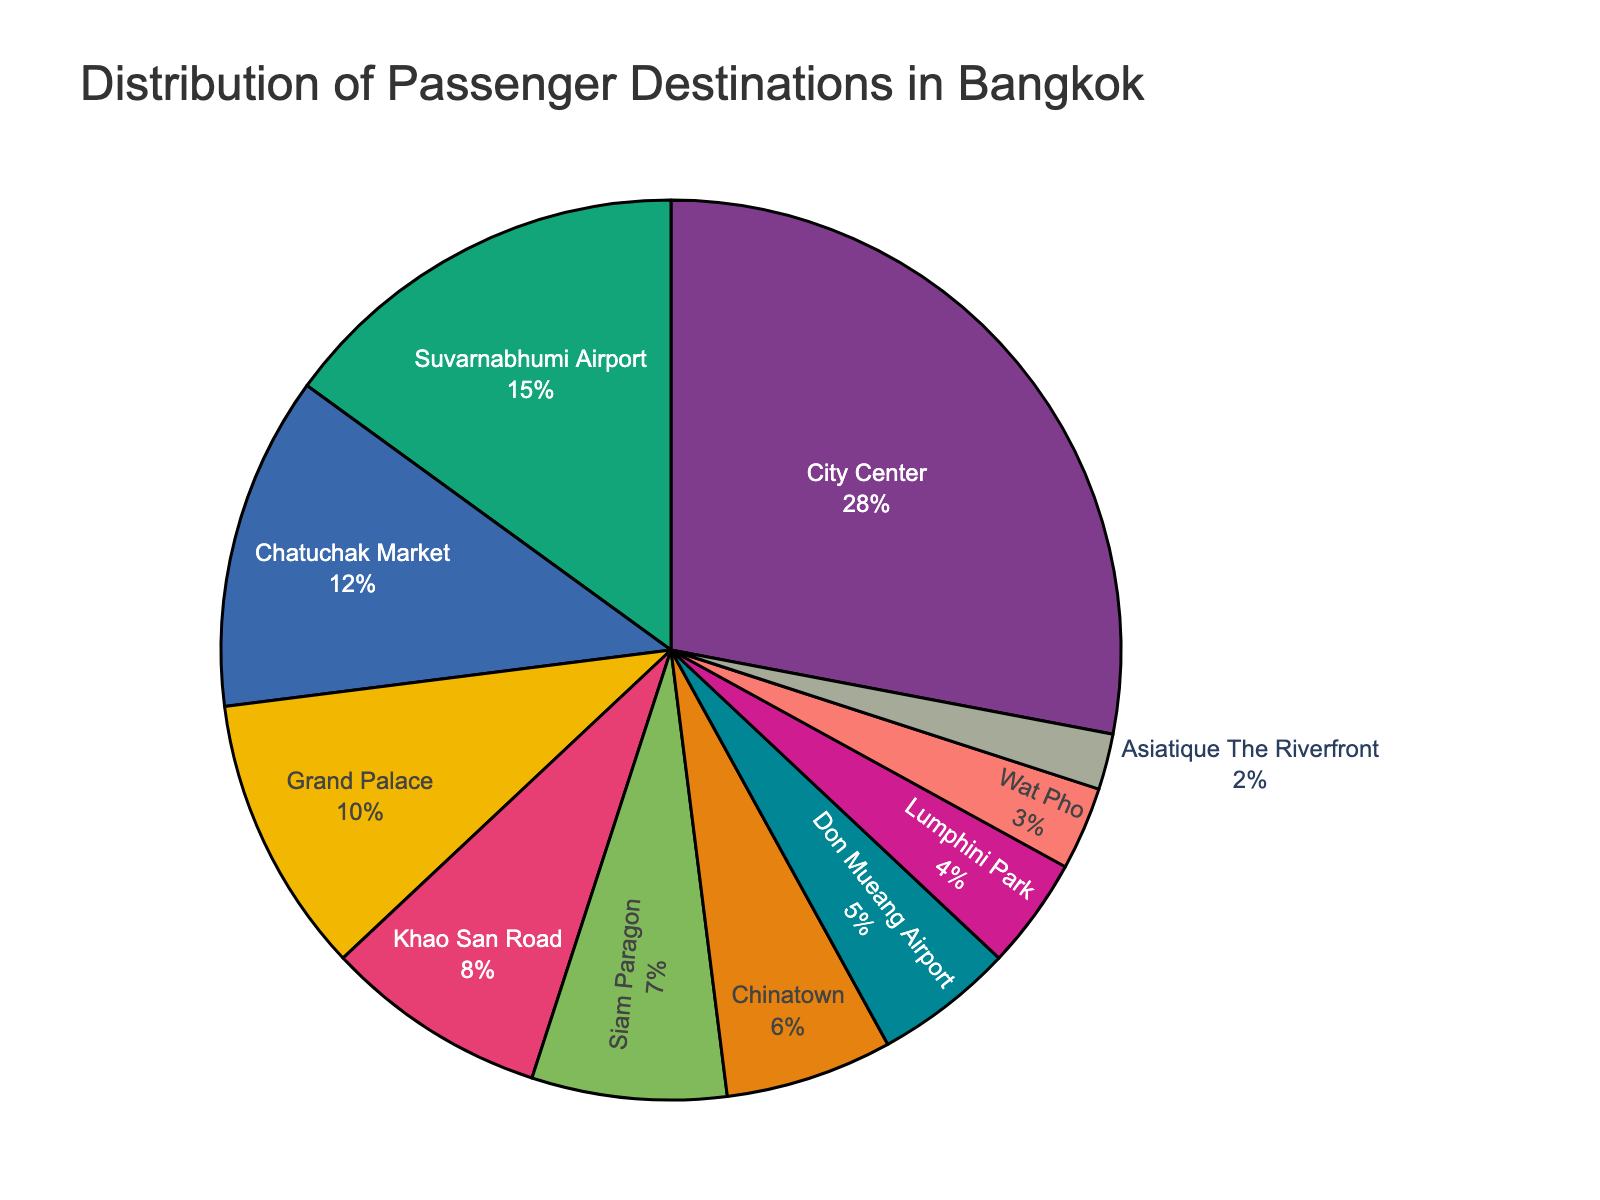Which destination has the highest percentage of passengers? Look for the slice of the pie chart that has the largest area. This slice is labeled "City Center" with 28%.
Answer: City Center What is the combined percentage of passengers going to the two airports? Identify the slices labeled "Suvarnabhumi Airport" and "Don Mueang Airport" and sum their percentages, 15% + 5%.
Answer: 20% Which destination has the smallest proportion of passengers? Find the smallest slice in the pie chart, which is labeled "Asiatique The Riverfront" with 2%.
Answer: Asiatique The Riverfront Are more passengers going to Chatuchak Market or Siam Paragon? Compare the sizes/percentages of the slices labeled "Chatuchak Market" (12%) and "Siam Paragon" (7%).
Answer: Chatuchak Market What is the difference in the percentage of passengers between the Grand Palace and Wat Pho? Subtract the percentage for Wat Pho (3%) from the percentage for Grand Palace (10%), 10% - 3%.
Answer: 7% If City Center and Suvarnabhumi Airport were combined into a single destination, what would their new percentage be? Sum the percentages of City Center (28%) and Suvarnabhumi Airport (15%), 28% + 15%.
Answer: 43% Which destination has a larger percentage of passengers: Khao San Road or Chinatown? Compare the percentages for Khao San Road (8%) and Chinatown (6%).
Answer: Khao San Road What percentage of passengers are going to tourist attractions (Chatuchak Market, Grand Palace, Wat Pho, Asiatique The Riverfront)? Sum the percentages for Chatuchak Market (12%), Grand Palace (10%), Wat Pho (3%), and Asiatique The Riverfront (2%), 12% + 10% + 3% + 2%.
Answer: 27% 